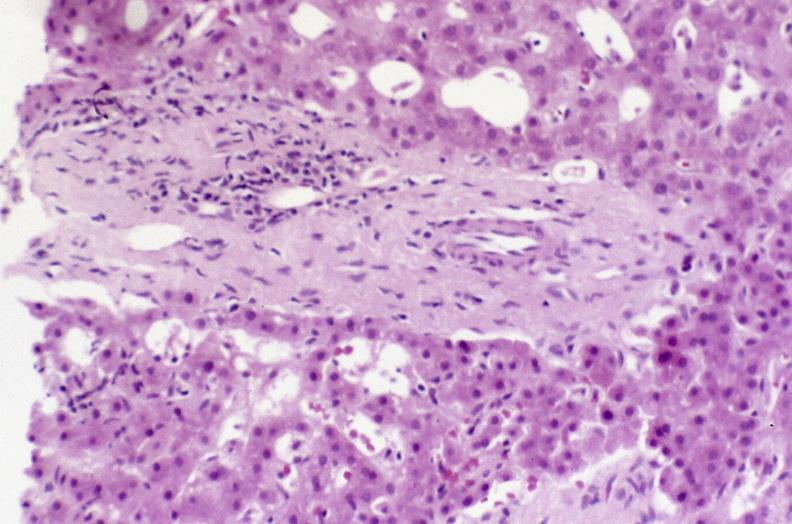s liver present?
Answer the question using a single word or phrase. Yes 